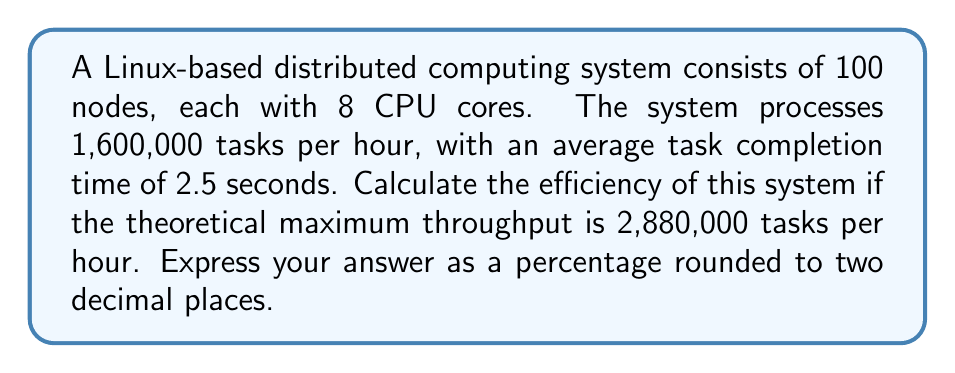What is the answer to this math problem? To calculate the efficiency of the Linux-based distributed computing system, we need to compare the actual performance with the theoretical maximum performance. Let's break this down step-by-step:

1. Calculate the total number of CPU cores in the system:
   $$ \text{Total cores} = 100 \text{ nodes} \times 8 \text{ cores/node} = 800 \text{ cores} $$

2. Calculate the actual throughput:
   $$ \text{Actual throughput} = 1,600,000 \text{ tasks/hour} $$

3. Given theoretical maximum throughput:
   $$ \text{Theoretical max throughput} = 2,880,000 \text{ tasks/hour} $$

4. Calculate the efficiency using the formula:
   $$ \text{Efficiency} = \frac{\text{Actual throughput}}{\text{Theoretical max throughput}} \times 100\% $$

5. Plug in the values:
   $$ \text{Efficiency} = \frac{1,600,000}{2,880,000} \times 100\% $$

6. Perform the calculation:
   $$ \text{Efficiency} = 0.5555555556 \times 100\% = 55.55555556\% $$

7. Round to two decimal places:
   $$ \text{Efficiency} \approx 55.56\% $$
Answer: 55.56% 